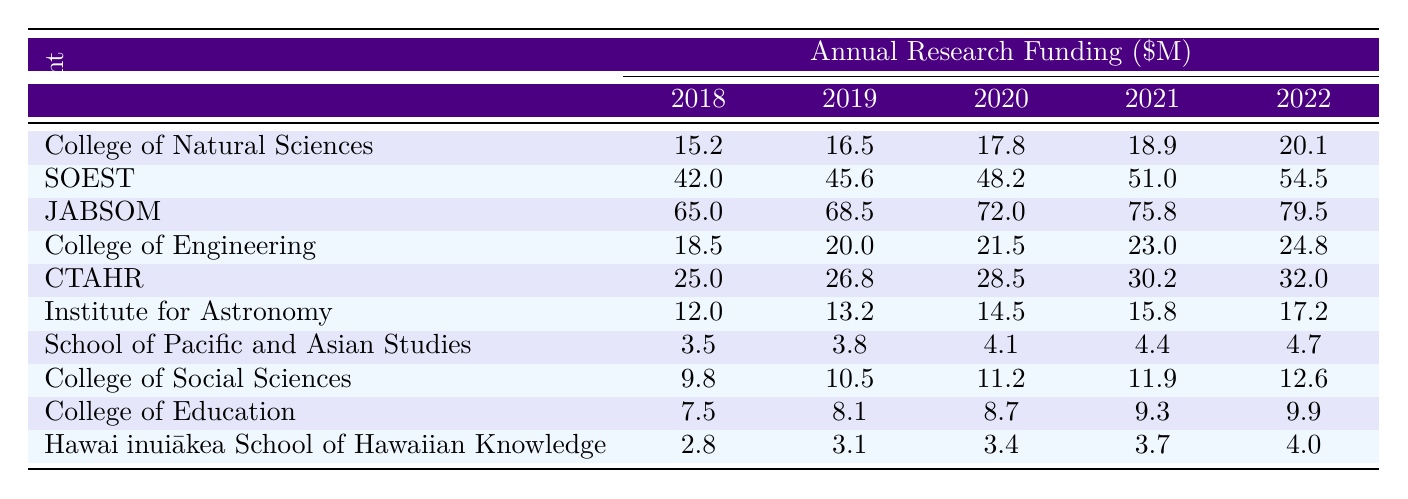What was the research funding for the John A. Burns School of Medicine in 2021? The table provides data for each department in 2021. For the John A. Burns School of Medicine, the funding amount listed is 75800000.
Answer: 75800000 Which department received the highest funding in 2022? To find this, we compare the funding amounts across all departments for 2022. The John A. Burns School of Medicine has the highest amount at 79500000.
Answer: John A. Burns School of Medicine What is the total research funding for the College of Natural Sciences from 2018 to 2022? We sum up the research funding amounts for the College of Natural Sciences over the years: 15200000 + 16500000 + 17800000 + 18900000 + 20100000 = 98500000.
Answer: 98500000 Did the funding for the School of Pacific and Asian Studies increase every year from 2018 to 2022? By checking the values for the School of Pacific and Asian Studies from 2018 to 2022 (3.5, 3.8, 4.1, 4.4, 4.7), we see that they consistently increase each year.
Answer: Yes What was the average research funding for the Institute for Astronomy over the five years? We calculate the average by summing the funding for each year: 12000000 + 13200000 + 14500000 + 15800000 + 17200000 = 72700000. Then we divide by the number of years (5): 72700000 / 5 = 14540000.
Answer: 14540000 What was the difference in funding for the College of Tropical Agriculture and Human Resources between 2020 and 2022? The funding amounts for CTAHR are 28500000 in 2020 and 32000000 in 2022. The difference is 32000000 - 28500000 = 3500000.
Answer: 3500000 Which departments had less than 10 million in funding in 2018? From the table, the departments with funding less than 10 million in 2018 are the School of Pacific and Asian Studies (3.5) and the Hawaiʻinuiākea School of Hawaiian Knowledge (2.8).
Answer: School of Pacific and Asian Studies, Hawaiʻinuiākea School of Hawaiian Knowledge Is it true that the College of Education had more than 8 million in funding every year? Looking at the College of Education's funding (7.5, 8.1, 8.7, 9.3, 9.9), it is only under 8 million in 2018.
Answer: No Which year had the highest total funding among all departments combined? First, we must sum the funding for each year from all departments. The total for each year is as follows: 2018: 15200000 + 42000000 + 65000000 + 18500000 + 25000000 + 12000000 + 3500000 + 9800000 + 7500000 + 2800000 = 171000000; 2019: 16500000 + 45600000 + 68500000 + 20000000 + 26800000 + 13200000 + 3800000 + 10500000 + 8100000 + 3100000 = 178800000; 2020: 17800000 + 48200000 + 72000000 + 21500000 + 28500000 + 14500000 + 4100000 + 11200000 + 8700000 + 3400000 = 186400000; 2021: 18900000 + 51000000 + 75800000 + 23000000 + 30200000 + 15800000 + 4400000 + 11900000 + 9300000 + 3700000 = 193700000; and 2022: 20100000 + 54500000 + 79500000 + 24800000 + 32000000 + 17200000 + 4700000 + 12600000 + 9900000 + 4000000 = 201000000. The highest total funding is in 2022.
Answer: 2022 What is the funding trend for the College of Engineering from 2018 to 2022? The College of Engineering’s funding amounts are increasing each year: 18500000 in 2018, up to 24800000 in 2022, indicating a consistent upward trend.
Answer: Increasing 